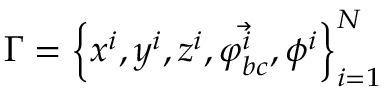Convert formula to latex. <formula><loc_0><loc_0><loc_500><loc_500>\Gamma = \left \{ x ^ { i } , y ^ { i } , z ^ { i } , \vec { \varphi _ { b c } ^ { i } } , \phi ^ { i } \right \} _ { i = 1 } ^ { N }</formula> 